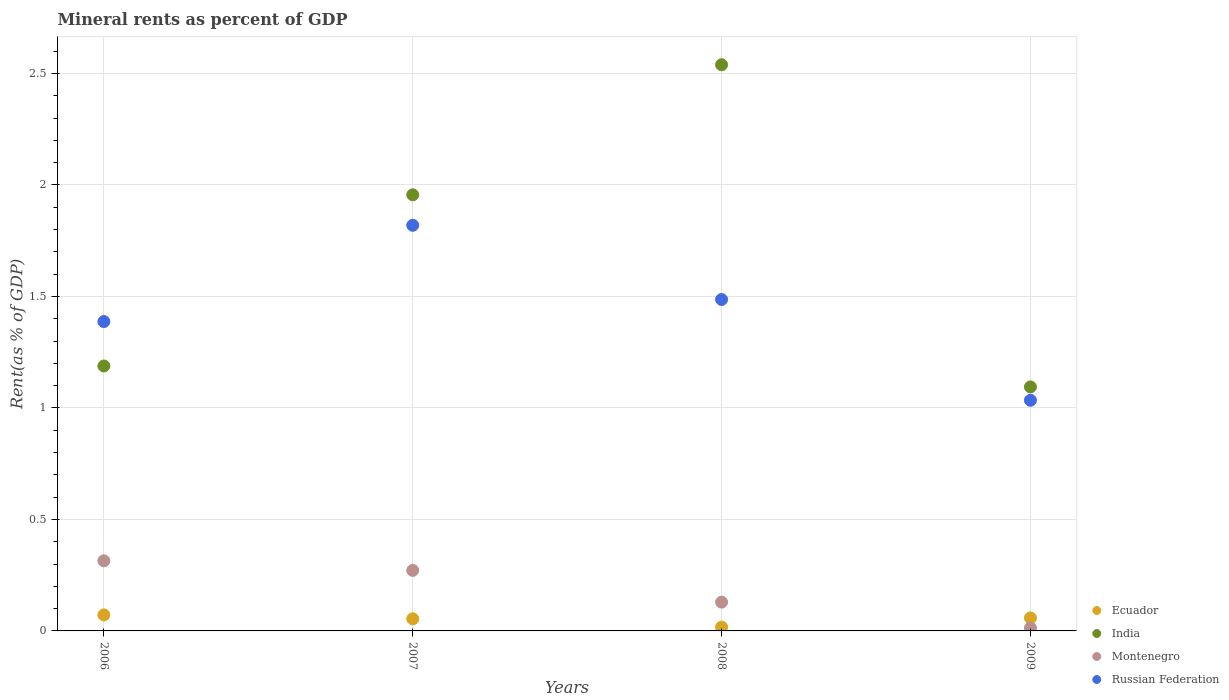What is the mineral rent in Montenegro in 2007?
Ensure brevity in your answer.  0.27. Across all years, what is the maximum mineral rent in India?
Keep it short and to the point. 2.54. Across all years, what is the minimum mineral rent in India?
Provide a succinct answer. 1.09. In which year was the mineral rent in Russian Federation maximum?
Provide a succinct answer. 2007. In which year was the mineral rent in India minimum?
Offer a terse response. 2009. What is the total mineral rent in Ecuador in the graph?
Your answer should be very brief. 0.2. What is the difference between the mineral rent in Montenegro in 2006 and that in 2009?
Offer a terse response. 0.3. What is the difference between the mineral rent in Russian Federation in 2006 and the mineral rent in Ecuador in 2009?
Offer a very short reply. 1.33. What is the average mineral rent in India per year?
Your response must be concise. 1.69. In the year 2007, what is the difference between the mineral rent in India and mineral rent in Ecuador?
Provide a short and direct response. 1.9. In how many years, is the mineral rent in Ecuador greater than 2.5 %?
Provide a succinct answer. 0. What is the ratio of the mineral rent in Montenegro in 2008 to that in 2009?
Your response must be concise. 9.93. Is the difference between the mineral rent in India in 2007 and 2008 greater than the difference between the mineral rent in Ecuador in 2007 and 2008?
Offer a very short reply. No. What is the difference between the highest and the second highest mineral rent in India?
Provide a succinct answer. 0.58. What is the difference between the highest and the lowest mineral rent in Ecuador?
Provide a short and direct response. 0.05. In how many years, is the mineral rent in Montenegro greater than the average mineral rent in Montenegro taken over all years?
Provide a short and direct response. 2. Does the mineral rent in India monotonically increase over the years?
Ensure brevity in your answer.  No. Is the mineral rent in Russian Federation strictly greater than the mineral rent in Montenegro over the years?
Provide a succinct answer. Yes. How many dotlines are there?
Your answer should be compact. 4. What is the difference between two consecutive major ticks on the Y-axis?
Keep it short and to the point. 0.5. Are the values on the major ticks of Y-axis written in scientific E-notation?
Your response must be concise. No. Where does the legend appear in the graph?
Your response must be concise. Bottom right. How many legend labels are there?
Keep it short and to the point. 4. What is the title of the graph?
Make the answer very short. Mineral rents as percent of GDP. Does "Croatia" appear as one of the legend labels in the graph?
Offer a terse response. No. What is the label or title of the Y-axis?
Offer a terse response. Rent(as % of GDP). What is the Rent(as % of GDP) in Ecuador in 2006?
Provide a succinct answer. 0.07. What is the Rent(as % of GDP) in India in 2006?
Give a very brief answer. 1.19. What is the Rent(as % of GDP) of Montenegro in 2006?
Your answer should be very brief. 0.31. What is the Rent(as % of GDP) in Russian Federation in 2006?
Give a very brief answer. 1.39. What is the Rent(as % of GDP) of Ecuador in 2007?
Keep it short and to the point. 0.05. What is the Rent(as % of GDP) in India in 2007?
Your answer should be compact. 1.96. What is the Rent(as % of GDP) in Montenegro in 2007?
Give a very brief answer. 0.27. What is the Rent(as % of GDP) in Russian Federation in 2007?
Provide a short and direct response. 1.82. What is the Rent(as % of GDP) of Ecuador in 2008?
Keep it short and to the point. 0.02. What is the Rent(as % of GDP) of India in 2008?
Provide a short and direct response. 2.54. What is the Rent(as % of GDP) in Montenegro in 2008?
Offer a terse response. 0.13. What is the Rent(as % of GDP) of Russian Federation in 2008?
Your answer should be compact. 1.49. What is the Rent(as % of GDP) of Ecuador in 2009?
Ensure brevity in your answer.  0.06. What is the Rent(as % of GDP) in India in 2009?
Your answer should be very brief. 1.09. What is the Rent(as % of GDP) of Montenegro in 2009?
Give a very brief answer. 0.01. What is the Rent(as % of GDP) in Russian Federation in 2009?
Ensure brevity in your answer.  1.03. Across all years, what is the maximum Rent(as % of GDP) in Ecuador?
Your answer should be very brief. 0.07. Across all years, what is the maximum Rent(as % of GDP) in India?
Your response must be concise. 2.54. Across all years, what is the maximum Rent(as % of GDP) in Montenegro?
Provide a succinct answer. 0.31. Across all years, what is the maximum Rent(as % of GDP) in Russian Federation?
Your answer should be very brief. 1.82. Across all years, what is the minimum Rent(as % of GDP) in Ecuador?
Your answer should be very brief. 0.02. Across all years, what is the minimum Rent(as % of GDP) of India?
Ensure brevity in your answer.  1.09. Across all years, what is the minimum Rent(as % of GDP) in Montenegro?
Make the answer very short. 0.01. Across all years, what is the minimum Rent(as % of GDP) in Russian Federation?
Give a very brief answer. 1.03. What is the total Rent(as % of GDP) of Ecuador in the graph?
Ensure brevity in your answer.  0.2. What is the total Rent(as % of GDP) of India in the graph?
Your answer should be very brief. 6.78. What is the total Rent(as % of GDP) of Montenegro in the graph?
Keep it short and to the point. 0.73. What is the total Rent(as % of GDP) of Russian Federation in the graph?
Provide a short and direct response. 5.73. What is the difference between the Rent(as % of GDP) in Ecuador in 2006 and that in 2007?
Provide a succinct answer. 0.02. What is the difference between the Rent(as % of GDP) in India in 2006 and that in 2007?
Provide a succinct answer. -0.77. What is the difference between the Rent(as % of GDP) in Montenegro in 2006 and that in 2007?
Your answer should be very brief. 0.04. What is the difference between the Rent(as % of GDP) in Russian Federation in 2006 and that in 2007?
Make the answer very short. -0.43. What is the difference between the Rent(as % of GDP) of Ecuador in 2006 and that in 2008?
Keep it short and to the point. 0.05. What is the difference between the Rent(as % of GDP) in India in 2006 and that in 2008?
Give a very brief answer. -1.35. What is the difference between the Rent(as % of GDP) of Montenegro in 2006 and that in 2008?
Provide a short and direct response. 0.19. What is the difference between the Rent(as % of GDP) of Russian Federation in 2006 and that in 2008?
Give a very brief answer. -0.1. What is the difference between the Rent(as % of GDP) of Ecuador in 2006 and that in 2009?
Offer a very short reply. 0.01. What is the difference between the Rent(as % of GDP) of India in 2006 and that in 2009?
Make the answer very short. 0.09. What is the difference between the Rent(as % of GDP) of Montenegro in 2006 and that in 2009?
Provide a short and direct response. 0.3. What is the difference between the Rent(as % of GDP) in Russian Federation in 2006 and that in 2009?
Your answer should be compact. 0.35. What is the difference between the Rent(as % of GDP) of Ecuador in 2007 and that in 2008?
Make the answer very short. 0.04. What is the difference between the Rent(as % of GDP) of India in 2007 and that in 2008?
Provide a short and direct response. -0.58. What is the difference between the Rent(as % of GDP) of Montenegro in 2007 and that in 2008?
Give a very brief answer. 0.14. What is the difference between the Rent(as % of GDP) in Russian Federation in 2007 and that in 2008?
Offer a very short reply. 0.33. What is the difference between the Rent(as % of GDP) of Ecuador in 2007 and that in 2009?
Provide a short and direct response. -0. What is the difference between the Rent(as % of GDP) in India in 2007 and that in 2009?
Your answer should be very brief. 0.86. What is the difference between the Rent(as % of GDP) in Montenegro in 2007 and that in 2009?
Your answer should be compact. 0.26. What is the difference between the Rent(as % of GDP) of Russian Federation in 2007 and that in 2009?
Your response must be concise. 0.78. What is the difference between the Rent(as % of GDP) in Ecuador in 2008 and that in 2009?
Your answer should be compact. -0.04. What is the difference between the Rent(as % of GDP) of India in 2008 and that in 2009?
Ensure brevity in your answer.  1.45. What is the difference between the Rent(as % of GDP) of Montenegro in 2008 and that in 2009?
Ensure brevity in your answer.  0.12. What is the difference between the Rent(as % of GDP) in Russian Federation in 2008 and that in 2009?
Make the answer very short. 0.45. What is the difference between the Rent(as % of GDP) in Ecuador in 2006 and the Rent(as % of GDP) in India in 2007?
Your answer should be compact. -1.88. What is the difference between the Rent(as % of GDP) in Ecuador in 2006 and the Rent(as % of GDP) in Montenegro in 2007?
Make the answer very short. -0.2. What is the difference between the Rent(as % of GDP) of Ecuador in 2006 and the Rent(as % of GDP) of Russian Federation in 2007?
Offer a terse response. -1.75. What is the difference between the Rent(as % of GDP) of India in 2006 and the Rent(as % of GDP) of Montenegro in 2007?
Offer a very short reply. 0.92. What is the difference between the Rent(as % of GDP) in India in 2006 and the Rent(as % of GDP) in Russian Federation in 2007?
Your answer should be very brief. -0.63. What is the difference between the Rent(as % of GDP) in Montenegro in 2006 and the Rent(as % of GDP) in Russian Federation in 2007?
Provide a succinct answer. -1.5. What is the difference between the Rent(as % of GDP) of Ecuador in 2006 and the Rent(as % of GDP) of India in 2008?
Your response must be concise. -2.47. What is the difference between the Rent(as % of GDP) of Ecuador in 2006 and the Rent(as % of GDP) of Montenegro in 2008?
Provide a short and direct response. -0.06. What is the difference between the Rent(as % of GDP) of Ecuador in 2006 and the Rent(as % of GDP) of Russian Federation in 2008?
Your answer should be very brief. -1.41. What is the difference between the Rent(as % of GDP) in India in 2006 and the Rent(as % of GDP) in Montenegro in 2008?
Your answer should be very brief. 1.06. What is the difference between the Rent(as % of GDP) in India in 2006 and the Rent(as % of GDP) in Russian Federation in 2008?
Keep it short and to the point. -0.3. What is the difference between the Rent(as % of GDP) of Montenegro in 2006 and the Rent(as % of GDP) of Russian Federation in 2008?
Offer a terse response. -1.17. What is the difference between the Rent(as % of GDP) of Ecuador in 2006 and the Rent(as % of GDP) of India in 2009?
Offer a very short reply. -1.02. What is the difference between the Rent(as % of GDP) in Ecuador in 2006 and the Rent(as % of GDP) in Montenegro in 2009?
Ensure brevity in your answer.  0.06. What is the difference between the Rent(as % of GDP) of Ecuador in 2006 and the Rent(as % of GDP) of Russian Federation in 2009?
Offer a terse response. -0.96. What is the difference between the Rent(as % of GDP) in India in 2006 and the Rent(as % of GDP) in Montenegro in 2009?
Your response must be concise. 1.18. What is the difference between the Rent(as % of GDP) of India in 2006 and the Rent(as % of GDP) of Russian Federation in 2009?
Your response must be concise. 0.15. What is the difference between the Rent(as % of GDP) in Montenegro in 2006 and the Rent(as % of GDP) in Russian Federation in 2009?
Provide a short and direct response. -0.72. What is the difference between the Rent(as % of GDP) of Ecuador in 2007 and the Rent(as % of GDP) of India in 2008?
Keep it short and to the point. -2.49. What is the difference between the Rent(as % of GDP) of Ecuador in 2007 and the Rent(as % of GDP) of Montenegro in 2008?
Give a very brief answer. -0.07. What is the difference between the Rent(as % of GDP) of Ecuador in 2007 and the Rent(as % of GDP) of Russian Federation in 2008?
Your answer should be very brief. -1.43. What is the difference between the Rent(as % of GDP) of India in 2007 and the Rent(as % of GDP) of Montenegro in 2008?
Offer a very short reply. 1.83. What is the difference between the Rent(as % of GDP) in India in 2007 and the Rent(as % of GDP) in Russian Federation in 2008?
Make the answer very short. 0.47. What is the difference between the Rent(as % of GDP) in Montenegro in 2007 and the Rent(as % of GDP) in Russian Federation in 2008?
Your answer should be very brief. -1.22. What is the difference between the Rent(as % of GDP) of Ecuador in 2007 and the Rent(as % of GDP) of India in 2009?
Give a very brief answer. -1.04. What is the difference between the Rent(as % of GDP) of Ecuador in 2007 and the Rent(as % of GDP) of Montenegro in 2009?
Your response must be concise. 0.04. What is the difference between the Rent(as % of GDP) in Ecuador in 2007 and the Rent(as % of GDP) in Russian Federation in 2009?
Ensure brevity in your answer.  -0.98. What is the difference between the Rent(as % of GDP) in India in 2007 and the Rent(as % of GDP) in Montenegro in 2009?
Your answer should be compact. 1.94. What is the difference between the Rent(as % of GDP) of India in 2007 and the Rent(as % of GDP) of Russian Federation in 2009?
Make the answer very short. 0.92. What is the difference between the Rent(as % of GDP) in Montenegro in 2007 and the Rent(as % of GDP) in Russian Federation in 2009?
Make the answer very short. -0.76. What is the difference between the Rent(as % of GDP) of Ecuador in 2008 and the Rent(as % of GDP) of India in 2009?
Your answer should be very brief. -1.08. What is the difference between the Rent(as % of GDP) of Ecuador in 2008 and the Rent(as % of GDP) of Montenegro in 2009?
Your answer should be compact. 0. What is the difference between the Rent(as % of GDP) of Ecuador in 2008 and the Rent(as % of GDP) of Russian Federation in 2009?
Provide a short and direct response. -1.02. What is the difference between the Rent(as % of GDP) in India in 2008 and the Rent(as % of GDP) in Montenegro in 2009?
Make the answer very short. 2.53. What is the difference between the Rent(as % of GDP) in India in 2008 and the Rent(as % of GDP) in Russian Federation in 2009?
Offer a terse response. 1.5. What is the difference between the Rent(as % of GDP) in Montenegro in 2008 and the Rent(as % of GDP) in Russian Federation in 2009?
Your response must be concise. -0.91. What is the average Rent(as % of GDP) of Ecuador per year?
Provide a short and direct response. 0.05. What is the average Rent(as % of GDP) of India per year?
Offer a terse response. 1.69. What is the average Rent(as % of GDP) in Montenegro per year?
Offer a very short reply. 0.18. What is the average Rent(as % of GDP) in Russian Federation per year?
Keep it short and to the point. 1.43. In the year 2006, what is the difference between the Rent(as % of GDP) in Ecuador and Rent(as % of GDP) in India?
Ensure brevity in your answer.  -1.12. In the year 2006, what is the difference between the Rent(as % of GDP) in Ecuador and Rent(as % of GDP) in Montenegro?
Your answer should be compact. -0.24. In the year 2006, what is the difference between the Rent(as % of GDP) in Ecuador and Rent(as % of GDP) in Russian Federation?
Provide a succinct answer. -1.32. In the year 2006, what is the difference between the Rent(as % of GDP) of India and Rent(as % of GDP) of Montenegro?
Make the answer very short. 0.87. In the year 2006, what is the difference between the Rent(as % of GDP) of India and Rent(as % of GDP) of Russian Federation?
Offer a very short reply. -0.2. In the year 2006, what is the difference between the Rent(as % of GDP) of Montenegro and Rent(as % of GDP) of Russian Federation?
Your answer should be compact. -1.07. In the year 2007, what is the difference between the Rent(as % of GDP) of Ecuador and Rent(as % of GDP) of India?
Ensure brevity in your answer.  -1.9. In the year 2007, what is the difference between the Rent(as % of GDP) of Ecuador and Rent(as % of GDP) of Montenegro?
Keep it short and to the point. -0.22. In the year 2007, what is the difference between the Rent(as % of GDP) of Ecuador and Rent(as % of GDP) of Russian Federation?
Your answer should be compact. -1.76. In the year 2007, what is the difference between the Rent(as % of GDP) in India and Rent(as % of GDP) in Montenegro?
Your response must be concise. 1.68. In the year 2007, what is the difference between the Rent(as % of GDP) of India and Rent(as % of GDP) of Russian Federation?
Keep it short and to the point. 0.14. In the year 2007, what is the difference between the Rent(as % of GDP) in Montenegro and Rent(as % of GDP) in Russian Federation?
Offer a very short reply. -1.55. In the year 2008, what is the difference between the Rent(as % of GDP) in Ecuador and Rent(as % of GDP) in India?
Your response must be concise. -2.52. In the year 2008, what is the difference between the Rent(as % of GDP) in Ecuador and Rent(as % of GDP) in Montenegro?
Offer a terse response. -0.11. In the year 2008, what is the difference between the Rent(as % of GDP) in Ecuador and Rent(as % of GDP) in Russian Federation?
Offer a terse response. -1.47. In the year 2008, what is the difference between the Rent(as % of GDP) in India and Rent(as % of GDP) in Montenegro?
Ensure brevity in your answer.  2.41. In the year 2008, what is the difference between the Rent(as % of GDP) of India and Rent(as % of GDP) of Russian Federation?
Make the answer very short. 1.05. In the year 2008, what is the difference between the Rent(as % of GDP) of Montenegro and Rent(as % of GDP) of Russian Federation?
Your response must be concise. -1.36. In the year 2009, what is the difference between the Rent(as % of GDP) of Ecuador and Rent(as % of GDP) of India?
Give a very brief answer. -1.04. In the year 2009, what is the difference between the Rent(as % of GDP) in Ecuador and Rent(as % of GDP) in Montenegro?
Your response must be concise. 0.05. In the year 2009, what is the difference between the Rent(as % of GDP) in Ecuador and Rent(as % of GDP) in Russian Federation?
Give a very brief answer. -0.98. In the year 2009, what is the difference between the Rent(as % of GDP) in India and Rent(as % of GDP) in Montenegro?
Give a very brief answer. 1.08. In the year 2009, what is the difference between the Rent(as % of GDP) in India and Rent(as % of GDP) in Russian Federation?
Your answer should be compact. 0.06. In the year 2009, what is the difference between the Rent(as % of GDP) in Montenegro and Rent(as % of GDP) in Russian Federation?
Provide a short and direct response. -1.02. What is the ratio of the Rent(as % of GDP) in Ecuador in 2006 to that in 2007?
Your response must be concise. 1.32. What is the ratio of the Rent(as % of GDP) of India in 2006 to that in 2007?
Offer a terse response. 0.61. What is the ratio of the Rent(as % of GDP) in Montenegro in 2006 to that in 2007?
Give a very brief answer. 1.16. What is the ratio of the Rent(as % of GDP) in Russian Federation in 2006 to that in 2007?
Your response must be concise. 0.76. What is the ratio of the Rent(as % of GDP) in Ecuador in 2006 to that in 2008?
Give a very brief answer. 4.19. What is the ratio of the Rent(as % of GDP) in India in 2006 to that in 2008?
Ensure brevity in your answer.  0.47. What is the ratio of the Rent(as % of GDP) of Montenegro in 2006 to that in 2008?
Ensure brevity in your answer.  2.44. What is the ratio of the Rent(as % of GDP) in Russian Federation in 2006 to that in 2008?
Your answer should be compact. 0.93. What is the ratio of the Rent(as % of GDP) of Ecuador in 2006 to that in 2009?
Provide a succinct answer. 1.23. What is the ratio of the Rent(as % of GDP) of India in 2006 to that in 2009?
Make the answer very short. 1.09. What is the ratio of the Rent(as % of GDP) in Montenegro in 2006 to that in 2009?
Ensure brevity in your answer.  24.2. What is the ratio of the Rent(as % of GDP) of Russian Federation in 2006 to that in 2009?
Offer a terse response. 1.34. What is the ratio of the Rent(as % of GDP) of Ecuador in 2007 to that in 2008?
Provide a succinct answer. 3.16. What is the ratio of the Rent(as % of GDP) of India in 2007 to that in 2008?
Ensure brevity in your answer.  0.77. What is the ratio of the Rent(as % of GDP) of Montenegro in 2007 to that in 2008?
Your answer should be very brief. 2.1. What is the ratio of the Rent(as % of GDP) in Russian Federation in 2007 to that in 2008?
Your response must be concise. 1.22. What is the ratio of the Rent(as % of GDP) in Ecuador in 2007 to that in 2009?
Your answer should be compact. 0.93. What is the ratio of the Rent(as % of GDP) in India in 2007 to that in 2009?
Provide a succinct answer. 1.79. What is the ratio of the Rent(as % of GDP) in Montenegro in 2007 to that in 2009?
Offer a very short reply. 20.89. What is the ratio of the Rent(as % of GDP) of Russian Federation in 2007 to that in 2009?
Provide a short and direct response. 1.76. What is the ratio of the Rent(as % of GDP) of Ecuador in 2008 to that in 2009?
Give a very brief answer. 0.29. What is the ratio of the Rent(as % of GDP) in India in 2008 to that in 2009?
Give a very brief answer. 2.32. What is the ratio of the Rent(as % of GDP) in Montenegro in 2008 to that in 2009?
Provide a succinct answer. 9.93. What is the ratio of the Rent(as % of GDP) of Russian Federation in 2008 to that in 2009?
Your response must be concise. 1.44. What is the difference between the highest and the second highest Rent(as % of GDP) of Ecuador?
Keep it short and to the point. 0.01. What is the difference between the highest and the second highest Rent(as % of GDP) in India?
Your answer should be compact. 0.58. What is the difference between the highest and the second highest Rent(as % of GDP) of Montenegro?
Offer a terse response. 0.04. What is the difference between the highest and the second highest Rent(as % of GDP) in Russian Federation?
Your answer should be compact. 0.33. What is the difference between the highest and the lowest Rent(as % of GDP) of Ecuador?
Your answer should be very brief. 0.05. What is the difference between the highest and the lowest Rent(as % of GDP) of India?
Keep it short and to the point. 1.45. What is the difference between the highest and the lowest Rent(as % of GDP) of Montenegro?
Keep it short and to the point. 0.3. What is the difference between the highest and the lowest Rent(as % of GDP) in Russian Federation?
Your answer should be compact. 0.78. 